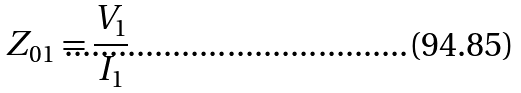<formula> <loc_0><loc_0><loc_500><loc_500>Z _ { 0 1 } = \frac { V _ { 1 } } { I _ { 1 } }</formula> 